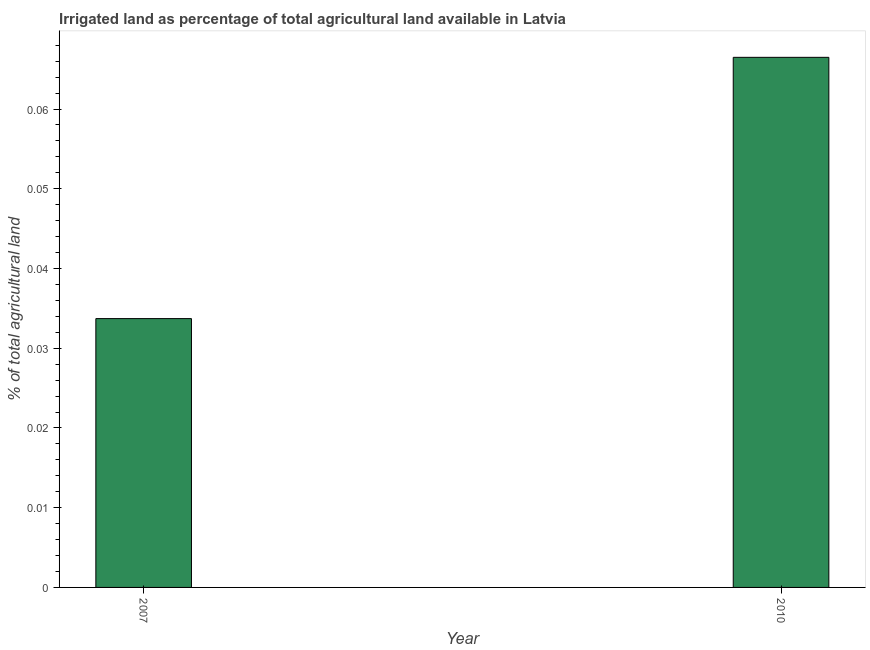Does the graph contain grids?
Offer a very short reply. No. What is the title of the graph?
Offer a terse response. Irrigated land as percentage of total agricultural land available in Latvia. What is the label or title of the X-axis?
Make the answer very short. Year. What is the label or title of the Y-axis?
Give a very brief answer. % of total agricultural land. What is the percentage of agricultural irrigated land in 2007?
Your response must be concise. 0.03. Across all years, what is the maximum percentage of agricultural irrigated land?
Your response must be concise. 0.07. Across all years, what is the minimum percentage of agricultural irrigated land?
Provide a short and direct response. 0.03. What is the sum of the percentage of agricultural irrigated land?
Ensure brevity in your answer.  0.1. What is the difference between the percentage of agricultural irrigated land in 2007 and 2010?
Provide a succinct answer. -0.03. What is the average percentage of agricultural irrigated land per year?
Give a very brief answer. 0.05. What is the median percentage of agricultural irrigated land?
Offer a terse response. 0.05. In how many years, is the percentage of agricultural irrigated land greater than 0.008 %?
Make the answer very short. 2. Do a majority of the years between 2007 and 2010 (inclusive) have percentage of agricultural irrigated land greater than 0.036 %?
Make the answer very short. No. What is the ratio of the percentage of agricultural irrigated land in 2007 to that in 2010?
Offer a terse response. 0.51. In how many years, is the percentage of agricultural irrigated land greater than the average percentage of agricultural irrigated land taken over all years?
Make the answer very short. 1. How many years are there in the graph?
Your answer should be compact. 2. Are the values on the major ticks of Y-axis written in scientific E-notation?
Provide a short and direct response. No. What is the % of total agricultural land in 2007?
Give a very brief answer. 0.03. What is the % of total agricultural land in 2010?
Provide a short and direct response. 0.07. What is the difference between the % of total agricultural land in 2007 and 2010?
Offer a very short reply. -0.03. What is the ratio of the % of total agricultural land in 2007 to that in 2010?
Make the answer very short. 0.51. 